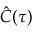Convert formula to latex. <formula><loc_0><loc_0><loc_500><loc_500>\hat { C } ( \tau )</formula> 